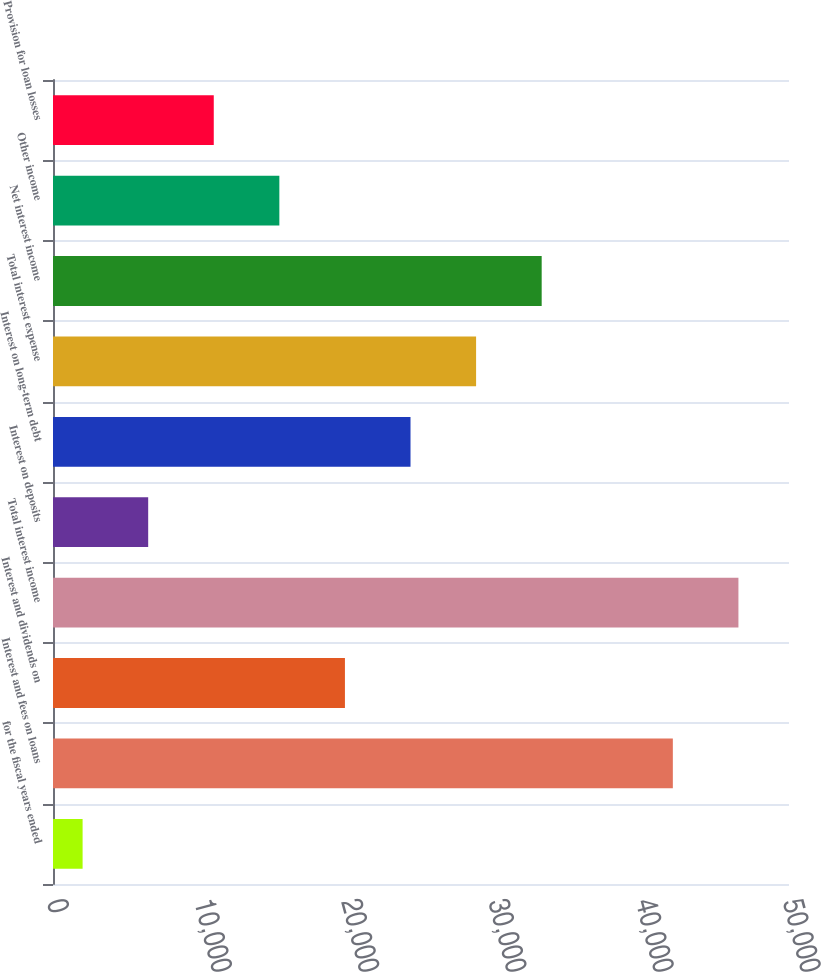Convert chart to OTSL. <chart><loc_0><loc_0><loc_500><loc_500><bar_chart><fcel>for the fiscal years ended<fcel>Interest and fees on loans<fcel>Interest and dividends on<fcel>Total interest income<fcel>Interest on deposits<fcel>Interest on long-term debt<fcel>Total interest expense<fcel>Net interest income<fcel>Other income<fcel>Provision for loan losses<nl><fcel>2011<fcel>42108.7<fcel>19832.2<fcel>46564<fcel>6466.3<fcel>24287.5<fcel>28742.8<fcel>33198.1<fcel>15376.9<fcel>10921.6<nl></chart> 